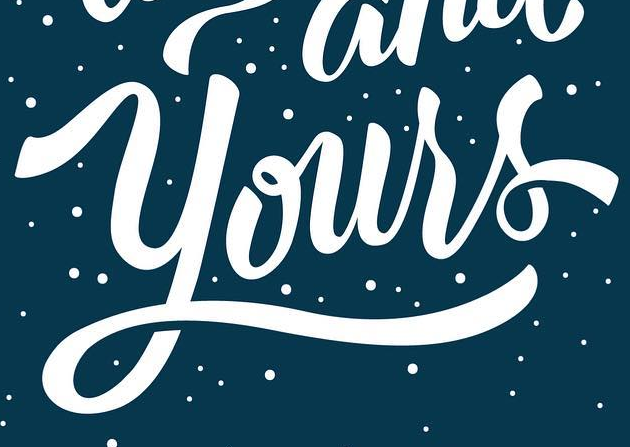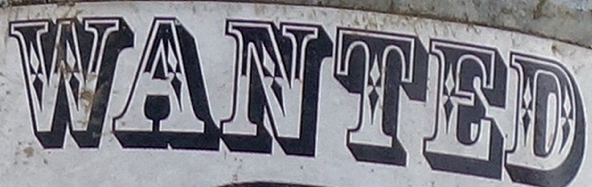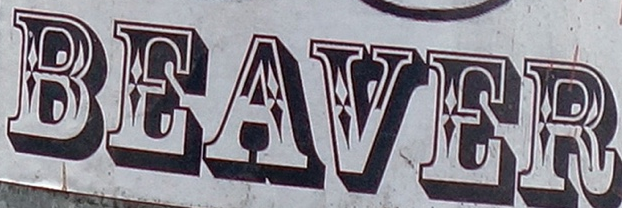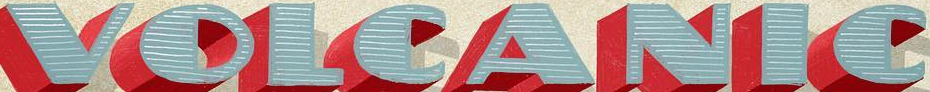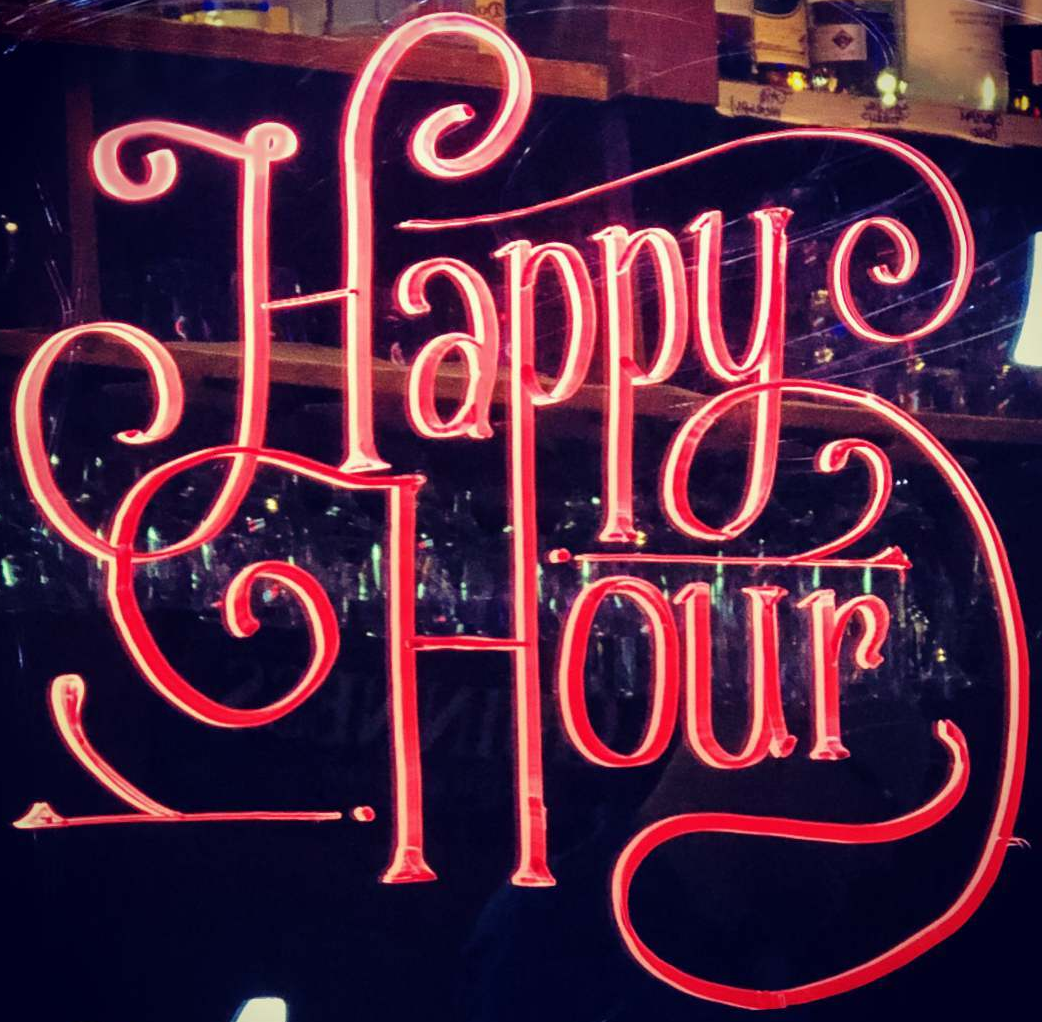Read the text content from these images in order, separated by a semicolon. Yours; WANTED; BEAVER; VOLCANIC; Happy 